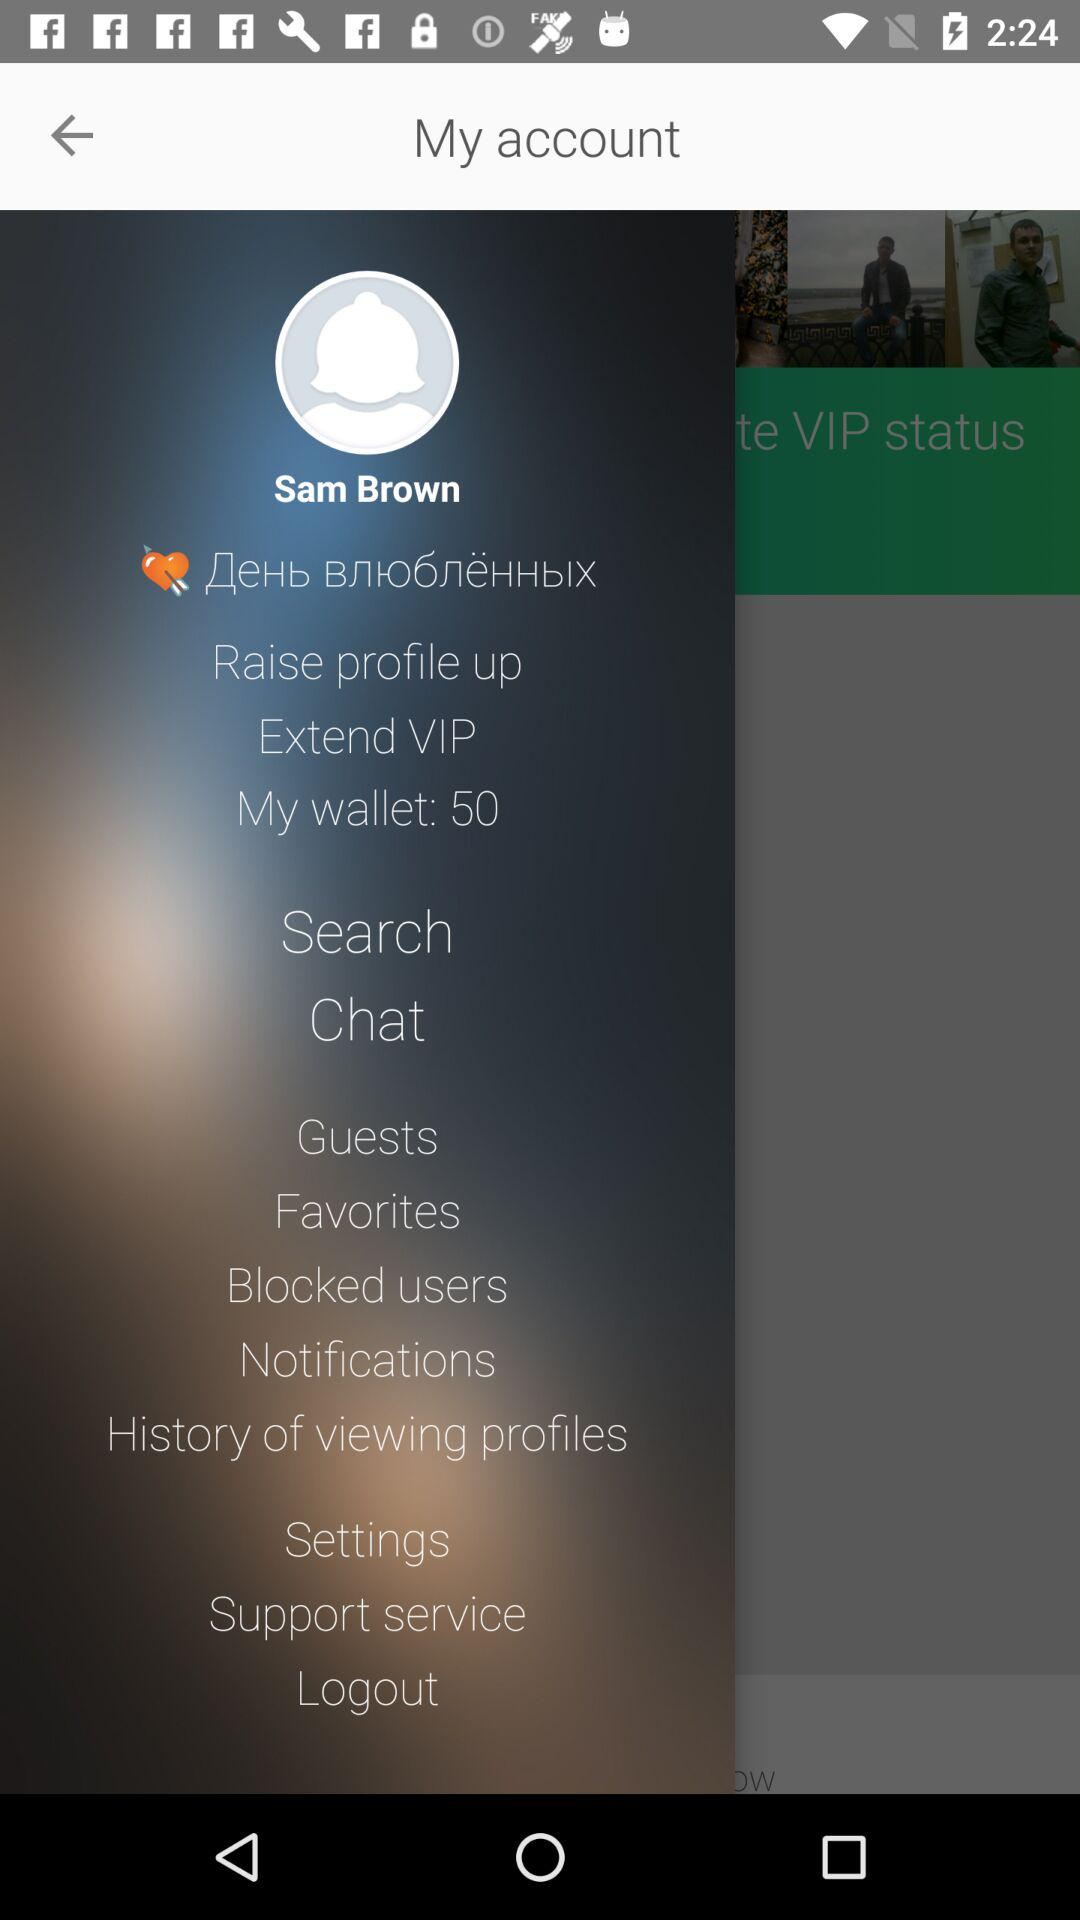What is the amount in my wallet? The amount in my wallet is 50. 